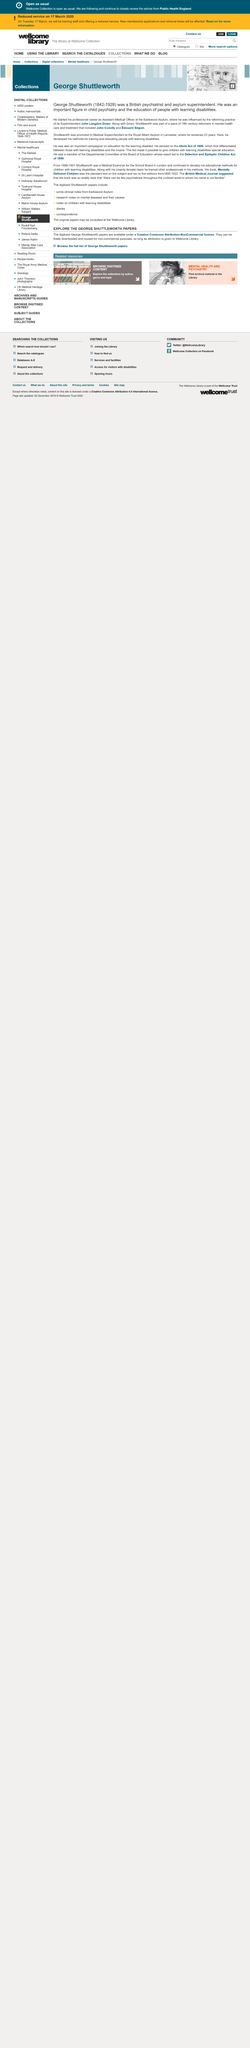Identify some key points in this picture. George Shuttleworth was born in 1842. Shuttleworth worked in an asylum as a superintendent, and this fact is true. The Idiots Act of 1886 made it possible for children with learning disabilities to receive special education. 